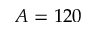Convert formula to latex. <formula><loc_0><loc_0><loc_500><loc_500>A = 1 2 0</formula> 